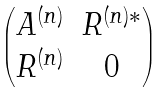<formula> <loc_0><loc_0><loc_500><loc_500>\begin{pmatrix} A ^ { ( n ) } & R ^ { ( n ) * } \\ R ^ { ( n ) } & 0 \end{pmatrix}</formula> 